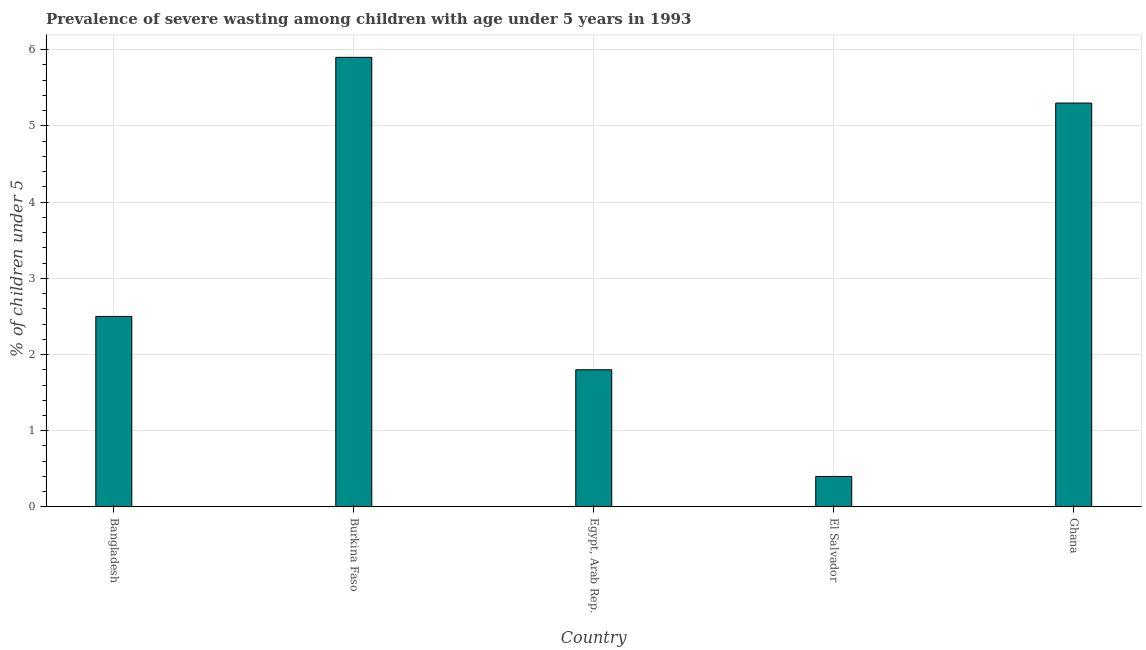Does the graph contain any zero values?
Keep it short and to the point. No. Does the graph contain grids?
Offer a very short reply. Yes. What is the title of the graph?
Your answer should be compact. Prevalence of severe wasting among children with age under 5 years in 1993. What is the label or title of the X-axis?
Provide a succinct answer. Country. What is the label or title of the Y-axis?
Make the answer very short.  % of children under 5. What is the prevalence of severe wasting in El Salvador?
Your response must be concise. 0.4. Across all countries, what is the maximum prevalence of severe wasting?
Your response must be concise. 5.9. Across all countries, what is the minimum prevalence of severe wasting?
Your answer should be compact. 0.4. In which country was the prevalence of severe wasting maximum?
Offer a very short reply. Burkina Faso. In which country was the prevalence of severe wasting minimum?
Your answer should be compact. El Salvador. What is the sum of the prevalence of severe wasting?
Offer a very short reply. 15.9. What is the average prevalence of severe wasting per country?
Your answer should be compact. 3.18. What is the ratio of the prevalence of severe wasting in El Salvador to that in Ghana?
Offer a very short reply. 0.07. Is the prevalence of severe wasting in Burkina Faso less than that in Ghana?
Keep it short and to the point. No. Is the difference between the prevalence of severe wasting in Bangladesh and Burkina Faso greater than the difference between any two countries?
Offer a terse response. No. What is the difference between the highest and the second highest prevalence of severe wasting?
Your answer should be very brief. 0.6. Is the sum of the prevalence of severe wasting in Burkina Faso and El Salvador greater than the maximum prevalence of severe wasting across all countries?
Provide a succinct answer. Yes. How many countries are there in the graph?
Ensure brevity in your answer.  5. What is the difference between two consecutive major ticks on the Y-axis?
Give a very brief answer. 1. What is the  % of children under 5 in Bangladesh?
Make the answer very short. 2.5. What is the  % of children under 5 in Burkina Faso?
Your answer should be very brief. 5.9. What is the  % of children under 5 of Egypt, Arab Rep.?
Ensure brevity in your answer.  1.8. What is the  % of children under 5 in El Salvador?
Ensure brevity in your answer.  0.4. What is the  % of children under 5 of Ghana?
Your response must be concise. 5.3. What is the difference between the  % of children under 5 in Bangladesh and Burkina Faso?
Give a very brief answer. -3.4. What is the difference between the  % of children under 5 in Bangladesh and Egypt, Arab Rep.?
Offer a very short reply. 0.7. What is the difference between the  % of children under 5 in Bangladesh and El Salvador?
Offer a terse response. 2.1. What is the difference between the  % of children under 5 in Bangladesh and Ghana?
Your response must be concise. -2.8. What is the difference between the  % of children under 5 in Egypt, Arab Rep. and El Salvador?
Offer a very short reply. 1.4. What is the difference between the  % of children under 5 in El Salvador and Ghana?
Your answer should be compact. -4.9. What is the ratio of the  % of children under 5 in Bangladesh to that in Burkina Faso?
Give a very brief answer. 0.42. What is the ratio of the  % of children under 5 in Bangladesh to that in Egypt, Arab Rep.?
Offer a terse response. 1.39. What is the ratio of the  % of children under 5 in Bangladesh to that in El Salvador?
Provide a succinct answer. 6.25. What is the ratio of the  % of children under 5 in Bangladesh to that in Ghana?
Your answer should be very brief. 0.47. What is the ratio of the  % of children under 5 in Burkina Faso to that in Egypt, Arab Rep.?
Give a very brief answer. 3.28. What is the ratio of the  % of children under 5 in Burkina Faso to that in El Salvador?
Make the answer very short. 14.75. What is the ratio of the  % of children under 5 in Burkina Faso to that in Ghana?
Your response must be concise. 1.11. What is the ratio of the  % of children under 5 in Egypt, Arab Rep. to that in Ghana?
Make the answer very short. 0.34. What is the ratio of the  % of children under 5 in El Salvador to that in Ghana?
Ensure brevity in your answer.  0.07. 